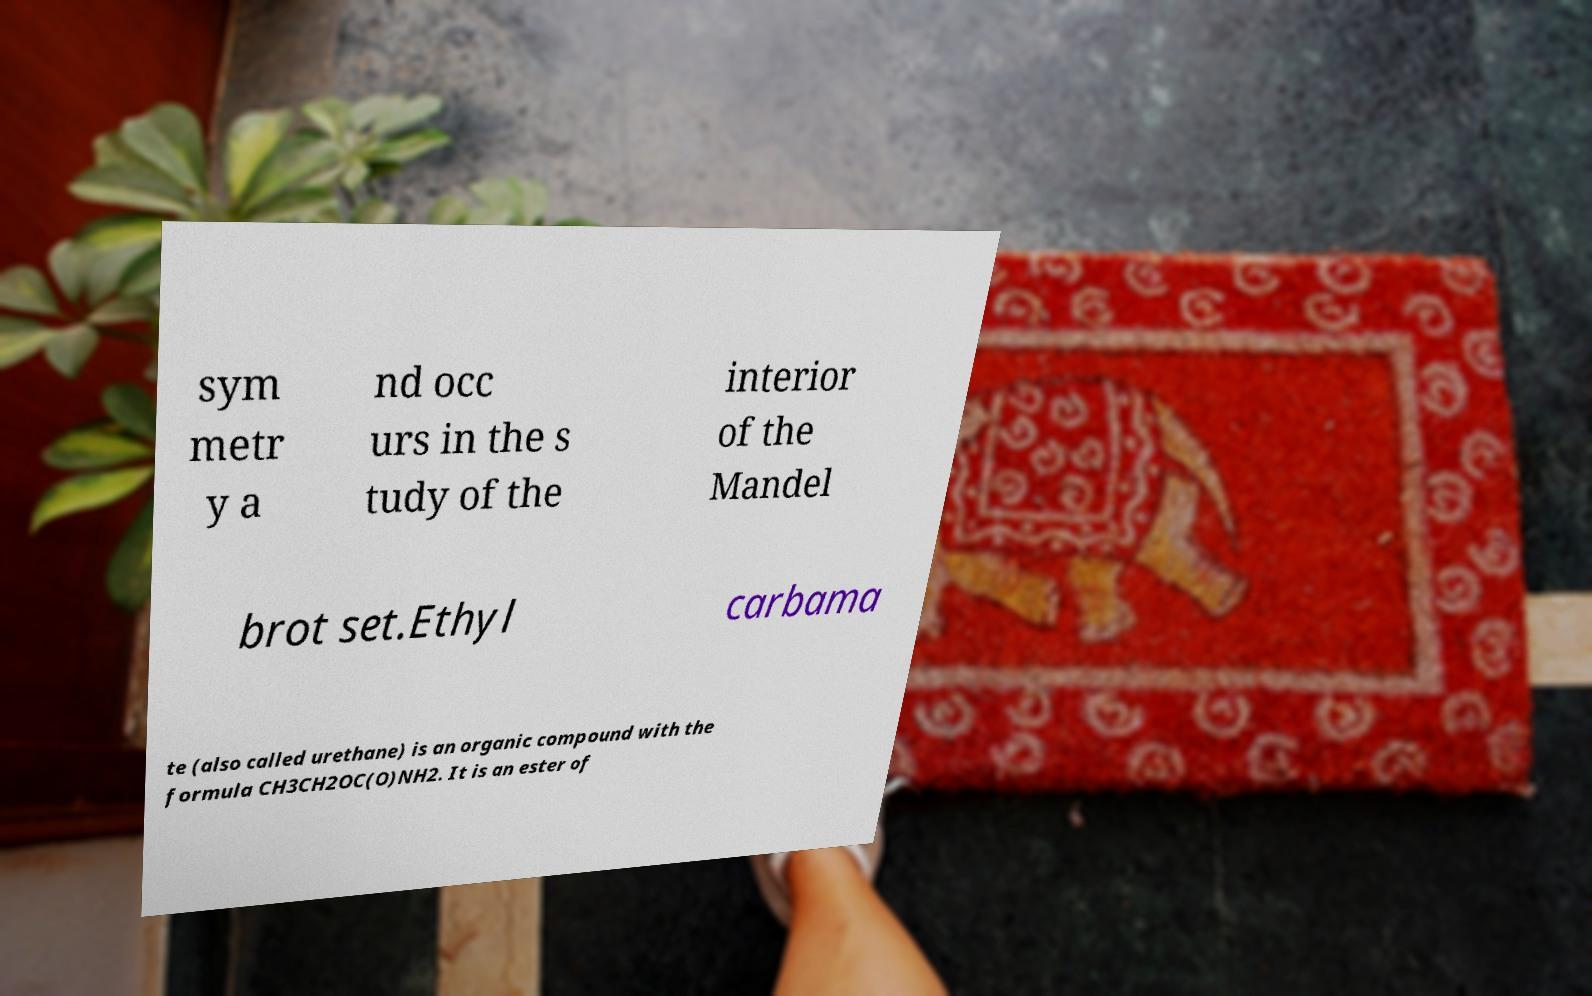Could you extract and type out the text from this image? sym metr y a nd occ urs in the s tudy of the interior of the Mandel brot set.Ethyl carbama te (also called urethane) is an organic compound with the formula CH3CH2OC(O)NH2. It is an ester of 